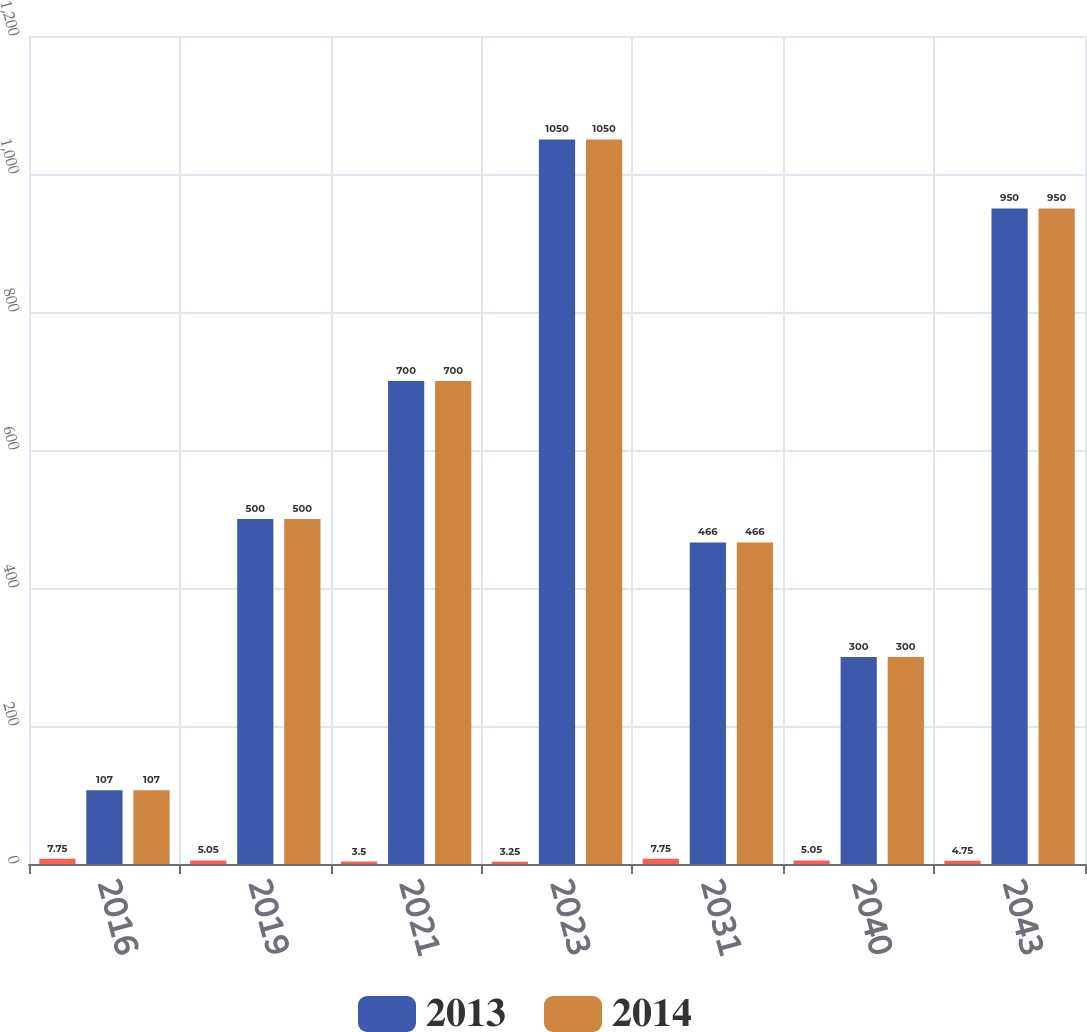Convert chart to OTSL. <chart><loc_0><loc_0><loc_500><loc_500><stacked_bar_chart><ecel><fcel>2016<fcel>2019<fcel>2021<fcel>2023<fcel>2031<fcel>2040<fcel>2043<nl><fcel>nan<fcel>7.75<fcel>5.05<fcel>3.5<fcel>3.25<fcel>7.75<fcel>5.05<fcel>4.75<nl><fcel>2013<fcel>107<fcel>500<fcel>700<fcel>1050<fcel>466<fcel>300<fcel>950<nl><fcel>2014<fcel>107<fcel>500<fcel>700<fcel>1050<fcel>466<fcel>300<fcel>950<nl></chart> 